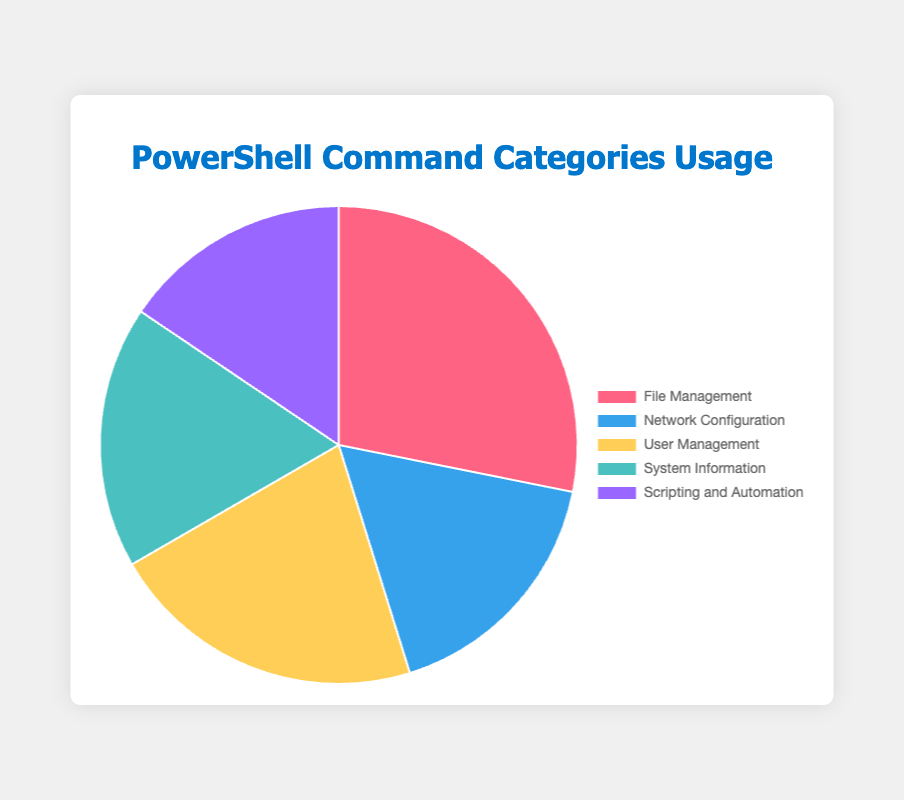What's the most used PowerShell command category in system administration tasks? The pie chart shows the percentage usage for each category. The category with the largest slice represents the highest usage.
Answer: File Management What's the least used PowerShell command category in system administration tasks? The pie chart shows the percentage usage for each category. The category with the smallest slice represents the least usage.
Answer: Scripting and Automation How much more is the usage percentage of File Management commands compared to User Management commands? Look at the pie chart slices for both categories. File Management has a larger slice. File Management's total usage is 38% (15+10+8+5). User Management's total usage is 29% (12+7+6+4). Subtract User Management usage from File Management.
Answer: 9% What is the total percentage covered by Network Configuration and System Information together? Look at the pie chart to find the percentages of Network Configuration and System Information. Network Configuration's total usage is 23% and System Information's total usage is 24%. Add these two percentages together.
Answer: 47% Which category has a larger usage: Network Configuration or Scripting and Automation? Compare the sizes of the slices for Network Configuration and Scripting and Automation in the pie chart. Network Configuration's usage is 23%, while Scripting and Automation's usage is 21%. Network Configuration is larger.
Answer: Network Configuration How does the usage of "Get-Item" in File Management compare to "Invoke-Command" in Scripting and Automation? Look at the individual command percentages within the categories on the chart. "Get-Item" in File Management is 15% and "Invoke-Command" in Scripting and Automation is 10%. "Get-Item" is more.
Answer: "Get-Item" is higher What portion of the chart does the combined usage of "Get-Process" and "Start-Job" commands take? Find the percentages for "Get-Process" (5%) and "Start-Job" (6%) in the pie chart. Add these two numbers together.
Answer: 11% Which command in User Management has the highest usage percentage? Look at the breakdown of commands in the User Management category on the pie chart. "Get-LocalUser" has the highest percentage at 12%.
Answer: "Get-LocalUser" How many categories have a total usage percentage above 30%? Look at the pie chart and identify the total percentage for each category. Only File Management (38%) exceeds 30%.
Answer: 1 category 